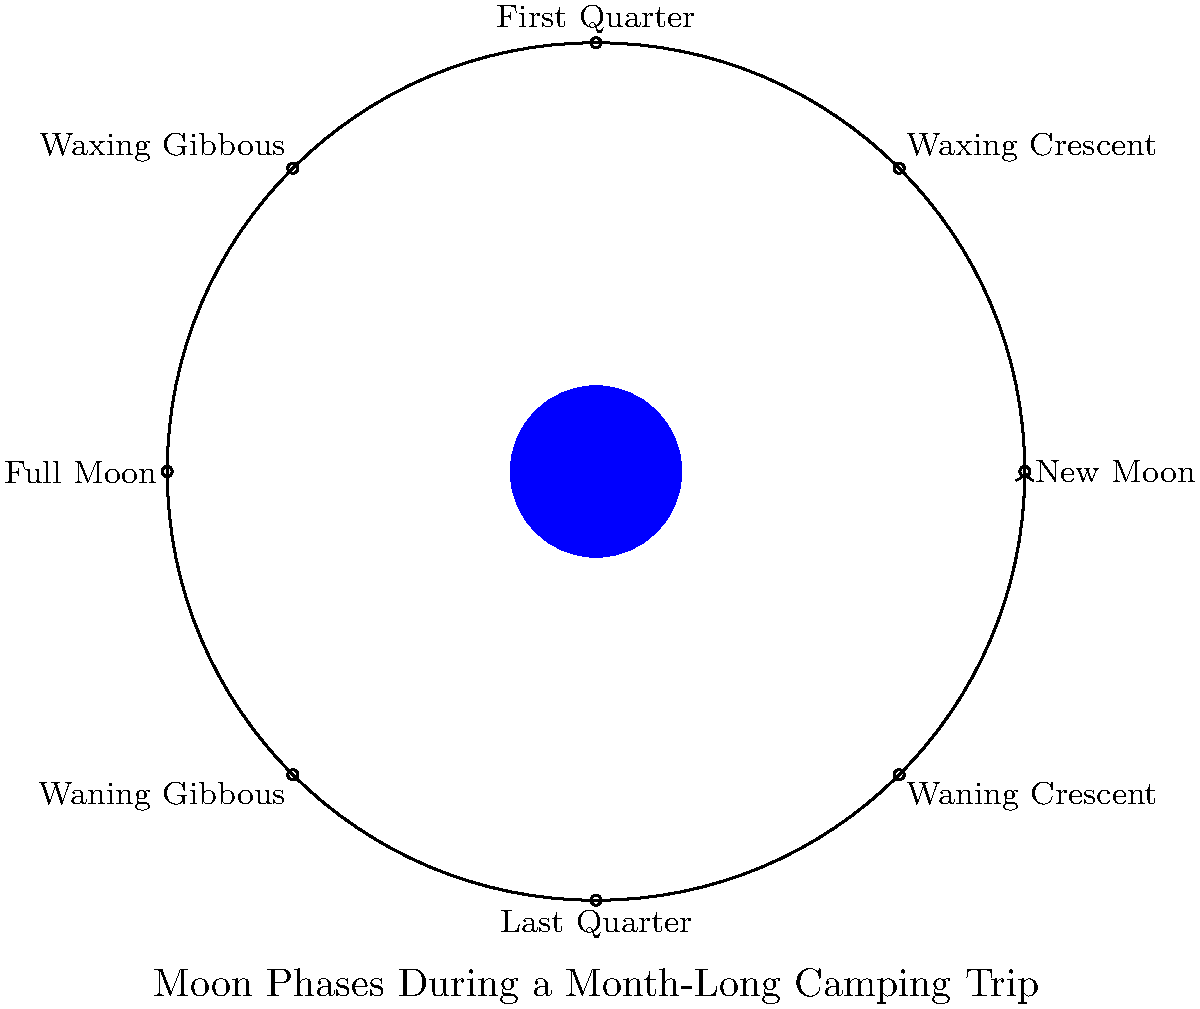During your month-long stargazing camping trip, you observe the moon's phases. Based on the diagram, if you start your trip on a New Moon, on which day of your trip would you expect to see the First Quarter moon? To determine when you'll see the First Quarter moon, follow these steps:

1. Understand the lunar cycle:
   - A complete lunar cycle (from one New Moon to the next) takes approximately 29.5 days.

2. Analyze the diagram:
   - The diagram shows 8 major phases of the moon in a circular arrangement.
   - Each phase is approximately 45° apart (360° ÷ 8 = 45°).

3. Locate the New Moon and First Quarter positions:
   - New Moon is at the top of the circle (0°).
   - First Quarter is 90° clockwise from the New Moon.

4. Calculate the time between phases:
   - Time between phases = (Days in lunar cycle × Degrees between phases) ÷ 360°
   - Time between phases = (29.5 × 90) ÷ 360 ≈ 7.375 days

5. Round to the nearest whole day:
   - 7.375 days rounds to 7 days

Therefore, you would expect to see the First Quarter moon approximately 7 days after the start of your trip.
Answer: 7 days 